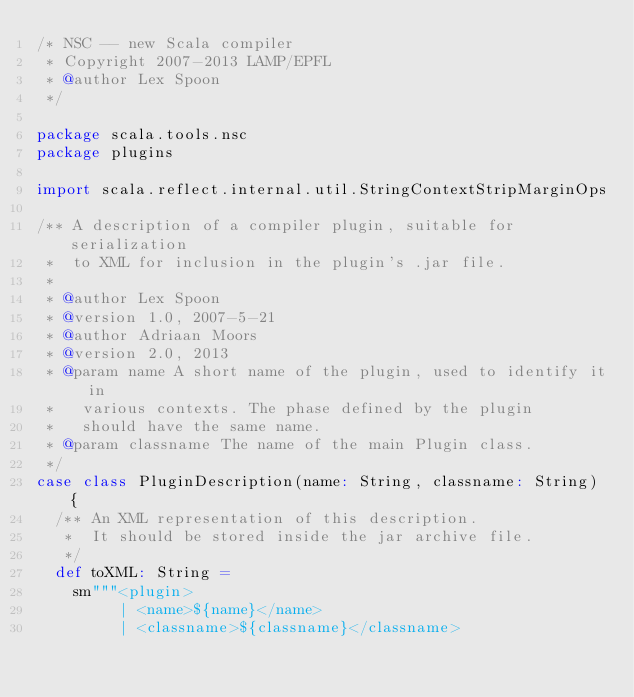Convert code to text. <code><loc_0><loc_0><loc_500><loc_500><_Scala_>/* NSC -- new Scala compiler
 * Copyright 2007-2013 LAMP/EPFL
 * @author Lex Spoon
 */

package scala.tools.nsc
package plugins

import scala.reflect.internal.util.StringContextStripMarginOps

/** A description of a compiler plugin, suitable for serialization
 *  to XML for inclusion in the plugin's .jar file.
 *
 * @author Lex Spoon
 * @version 1.0, 2007-5-21
 * @author Adriaan Moors
 * @version 2.0, 2013
 * @param name A short name of the plugin, used to identify it in
 *   various contexts. The phase defined by the plugin
 *   should have the same name.
 * @param classname The name of the main Plugin class.
 */
case class PluginDescription(name: String, classname: String) {
  /** An XML representation of this description.
   *  It should be stored inside the jar archive file.
   */
  def toXML: String =
    sm"""<plugin>
         | <name>${name}</name>
         | <classname>${classname}</classname></code> 